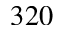Convert formula to latex. <formula><loc_0><loc_0><loc_500><loc_500>3 2 0</formula> 